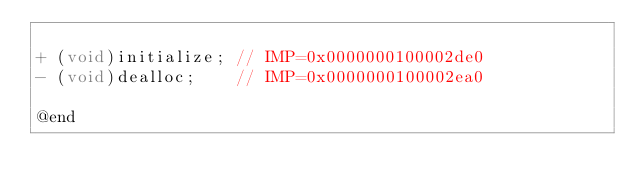<code> <loc_0><loc_0><loc_500><loc_500><_C_>
+ (void)initialize;	// IMP=0x0000000100002de0
- (void)dealloc;	// IMP=0x0000000100002ea0

@end

</code> 